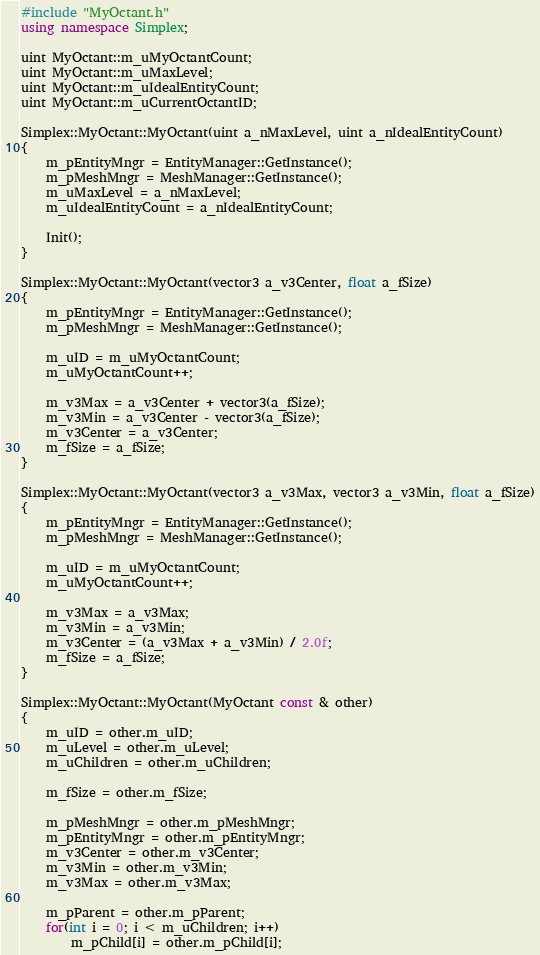Convert code to text. <code><loc_0><loc_0><loc_500><loc_500><_C++_>#include "MyOctant.h"
using namespace Simplex;

uint MyOctant::m_uMyOctantCount;
uint MyOctant::m_uMaxLevel;
uint MyOctant::m_uIdealEntityCount;
uint MyOctant::m_uCurrentOctantID;

Simplex::MyOctant::MyOctant(uint a_nMaxLevel, uint a_nIdealEntityCount)
{
	m_pEntityMngr = EntityManager::GetInstance();
	m_pMeshMngr = MeshManager::GetInstance();
	m_uMaxLevel = a_nMaxLevel;
	m_uIdealEntityCount = a_nIdealEntityCount;

	Init();
}

Simplex::MyOctant::MyOctant(vector3 a_v3Center, float a_fSize)
{
	m_pEntityMngr = EntityManager::GetInstance();
	m_pMeshMngr = MeshManager::GetInstance();

	m_uID = m_uMyOctantCount;
	m_uMyOctantCount++;

	m_v3Max = a_v3Center + vector3(a_fSize);
	m_v3Min = a_v3Center - vector3(a_fSize);
	m_v3Center = a_v3Center;
	m_fSize = a_fSize;
}

Simplex::MyOctant::MyOctant(vector3 a_v3Max, vector3 a_v3Min, float a_fSize)
{
	m_pEntityMngr = EntityManager::GetInstance();
	m_pMeshMngr = MeshManager::GetInstance();

	m_uID = m_uMyOctantCount;
	m_uMyOctantCount++;

	m_v3Max = a_v3Max;
	m_v3Min = a_v3Min;
	m_v3Center = (a_v3Max + a_v3Min) / 2.0f;
	m_fSize = a_fSize;
}

Simplex::MyOctant::MyOctant(MyOctant const & other)
{
	m_uID = other.m_uID;
	m_uLevel = other.m_uLevel;
	m_uChildren = other.m_uChildren;

	m_fSize = other.m_fSize;

	m_pMeshMngr = other.m_pMeshMngr;
	m_pEntityMngr = other.m_pEntityMngr;
	m_v3Center = other.m_v3Center;
	m_v3Min = other.m_v3Min;
	m_v3Max = other.m_v3Max;

	m_pParent = other.m_pParent;
	for(int i = 0; i < m_uChildren; i++)
		m_pChild[i] = other.m_pChild[i];
</code> 